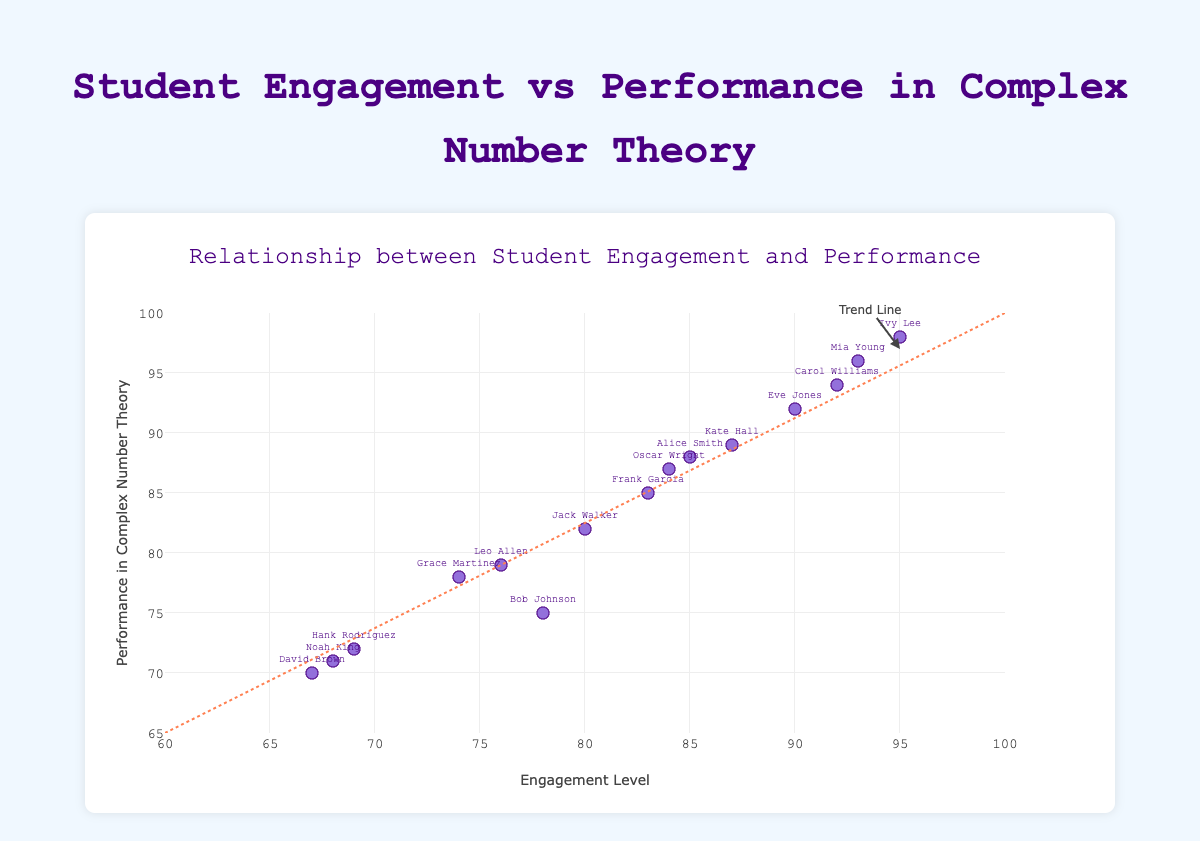What is the title of the scatter plot? The title of the scatter plot is prominently displayed at the top of the chart.
Answer: Student Engagement vs Performance in Complex Number Theory How many students' data points are shown in the scatter plot? Count the number of markers or the number of names labeled on the markers in the plot.
Answer: 15 What are the x-axis and y-axis labels? The labels for the axes are given in the plot, with the x-axis usually at the bottom and the y-axis to the left side of the plot. The x-axis label is 'Engagement Level' and the y-axis label is 'Performance in Complex Number Theory'.
Answer: Engagement Level and Performance in Complex Number Theory What is the color of the markers in the scatter plot? The color of the markers is uniform and can be observed directly in the plot.
Answer: Purple Which student has the highest engagement level and what is their performance in CNM? Identify the data point at the highest engagement level on the x-axis and read off the corresponding y-axis value and student label. The highest engagement level is 95, belonging to Ivy Lee who has a performance of 98.
Answer: Ivy Lee, 98 Is there a general trend between engagement level and performance in CNM? Look for the annotations and additional elements in the scatter plot, such as a trend line or its label. The trend line and annotations indicate that higher engagement levels are generally associated with higher performance in CNM.
Answer: Yes, higher engagement tends to correlate with higher performance Identify two students with roughly equal engagement levels and compare their performances. Select two students close to each other on the x-axis and compare their y-values. For example, Jack Walker (80 engagement, 82 performance) and Frank Garcia (83 engagement, 85 performance) have similar engagement levels; Frank performs slightly better than Jack.
Answer: Jack Walker and Frank Garcia; Frank performs slightly better Which student performs better, David Brown or Noah King? Locate the markers for David Brown and Noah King on the plot. David Brown's performance is 70, and Noah King's performance is 71, so Noah performs slightly better.
Answer: Noah King Calculate the average engagement level of the students with performances above 90. First, identify the students with performances above 90. The students are Alice Smith, Carol Williams, Eve Jones, Ivy Lee, Kate Hall, Mia Young, and Oscar Wright. Sum their engagement levels (85 + 92 + 90 + 95 + 87 + 93 + 84) which is 626, then divide by the number of these students, which is 7.
Answer: 89.43 Is there an outlier when comparing engagement levels and performances? Look across the scatter plot to identify any data point that deviates significantly from the trend line or from other data points. No significant outliers are present as all data points seem to follow the general trend.
Answer: No 